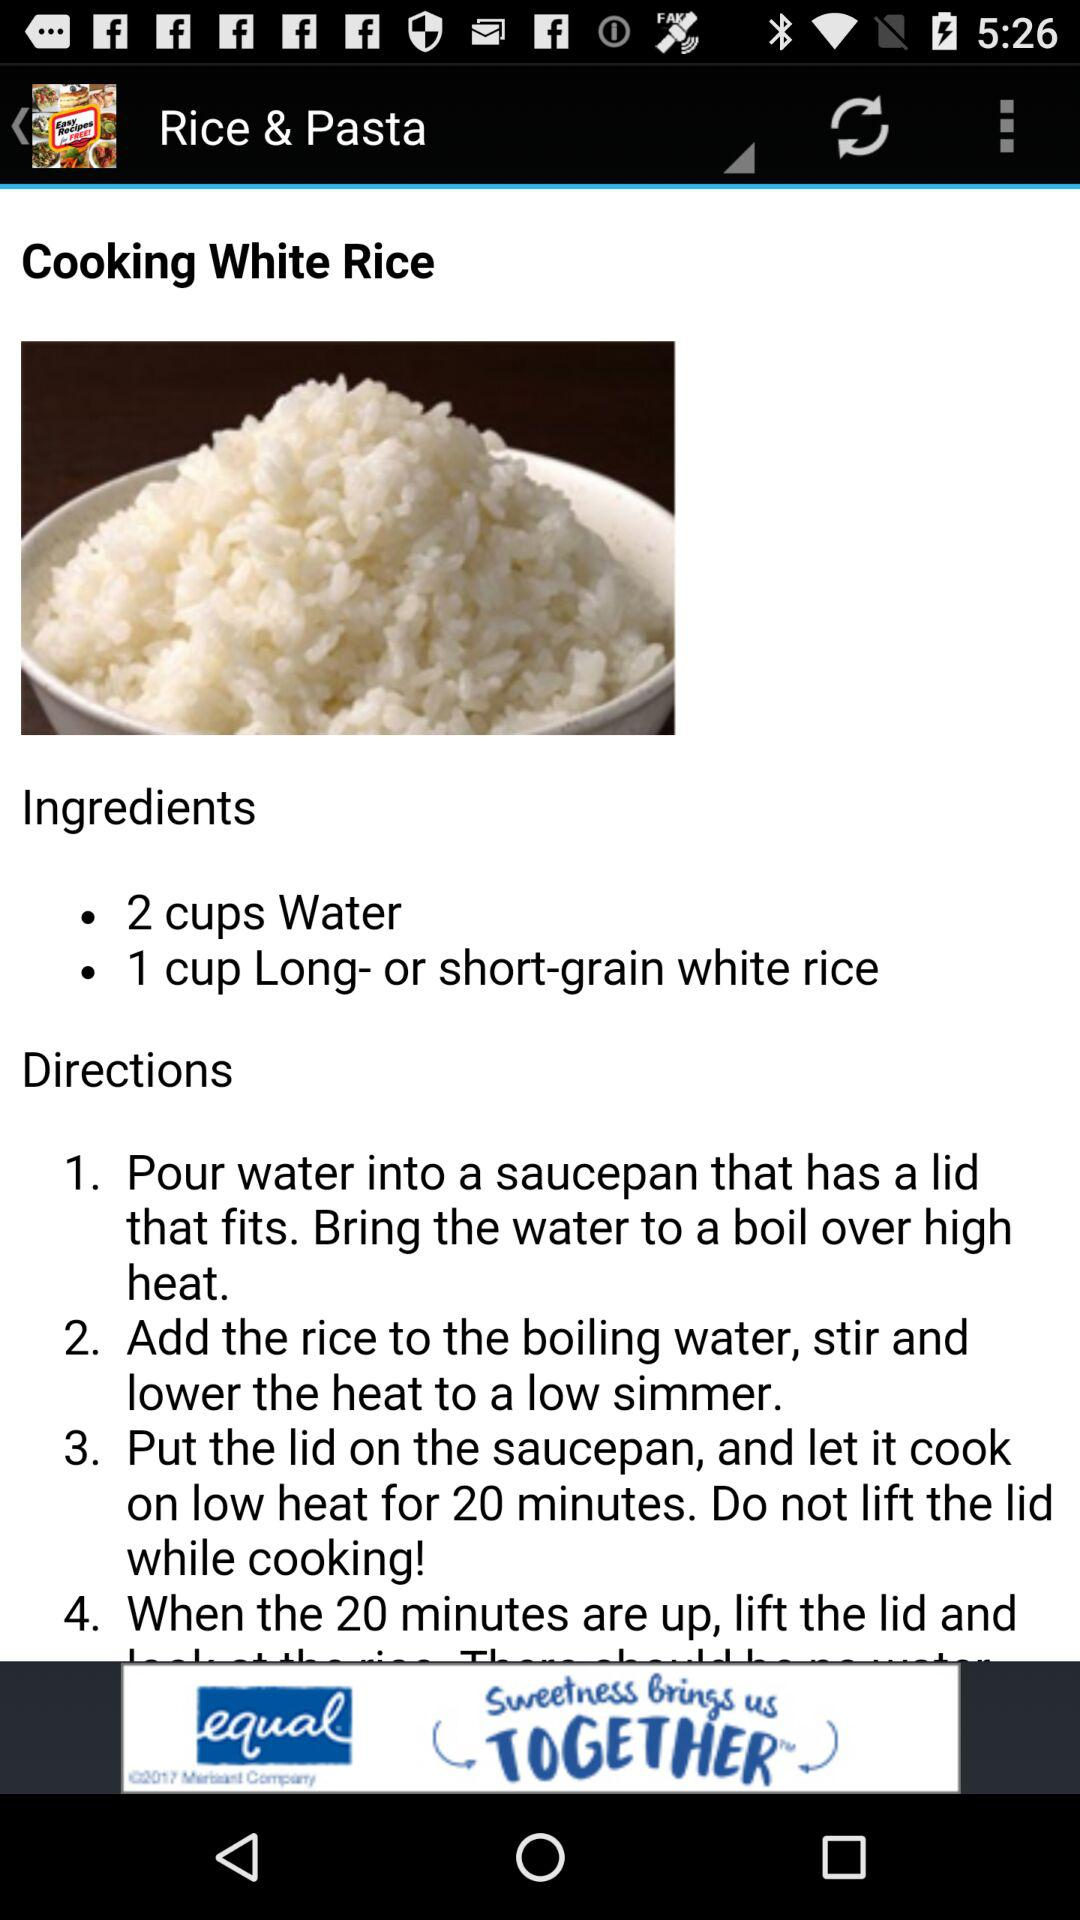Into what utensil do we have to pour the water? You have to pour the water into a saucepan that has a lid that fits. 